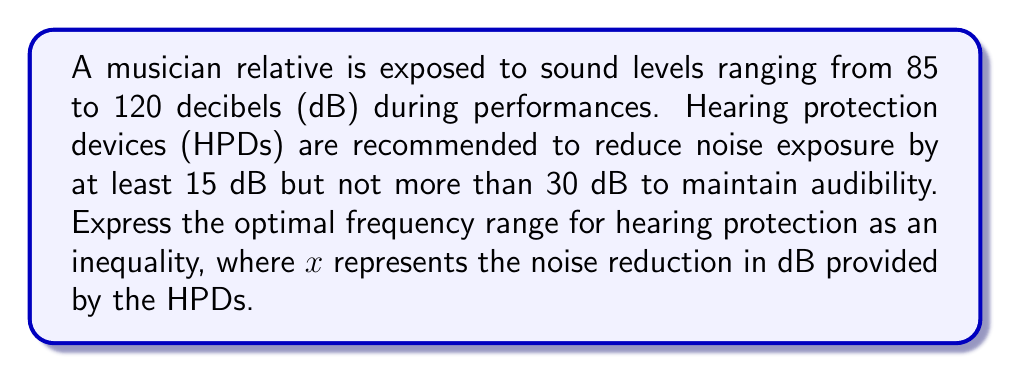Teach me how to tackle this problem. 1. The minimum noise reduction required:
   $85 \text{ dB} - x \leq 70 \text{ dB}$
   $-x \leq -15$
   $x \geq 15$

2. The maximum noise reduction allowed:
   $120 \text{ dB} - x \geq 90 \text{ dB}$
   $-x \geq -30$
   $x \leq 30$

3. Combining the two inequalities:
   $15 \leq x \leq 30$

This inequality represents the optimal frequency range for hearing protection, where $x$ is the noise reduction in dB provided by the HPDs.
Answer: $15 \leq x \leq 30$ 